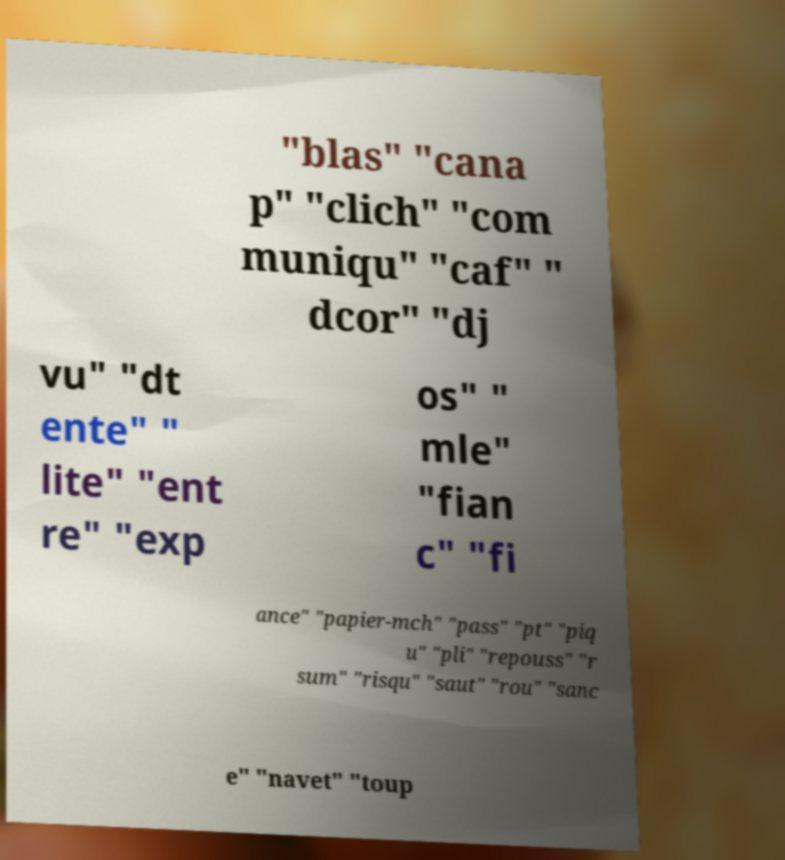Please read and relay the text visible in this image. What does it say? "blas" "cana p" "clich" "com muniqu" "caf" " dcor" "dj vu" "dt ente" " lite" "ent re" "exp os" " mle" "fian c" "fi ance" "papier-mch" "pass" "pt" "piq u" "pli" "repouss" "r sum" "risqu" "saut" "rou" "sanc e" "navet" "toup 